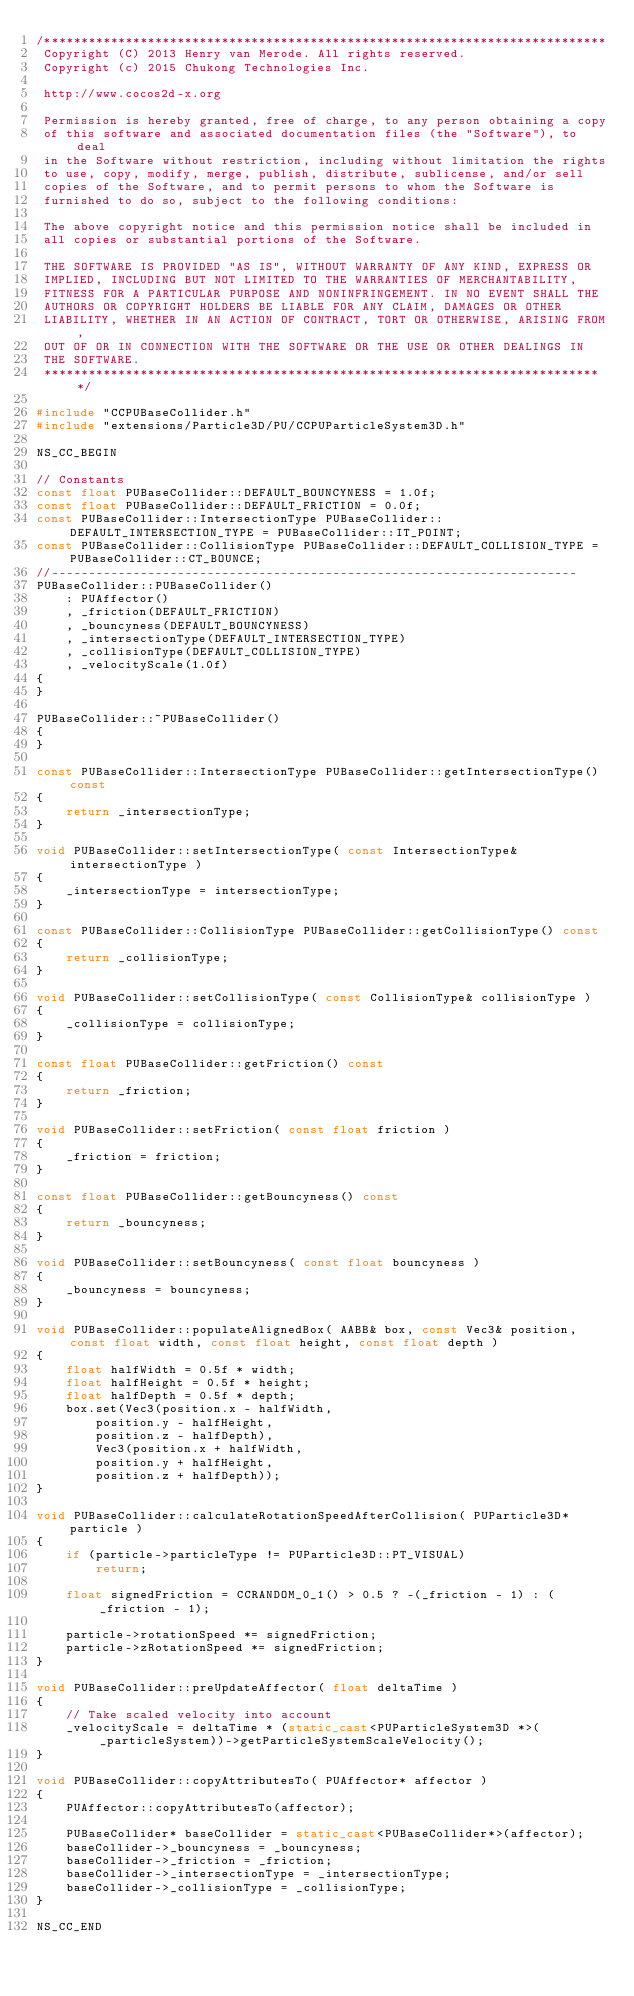Convert code to text. <code><loc_0><loc_0><loc_500><loc_500><_C++_>/****************************************************************************
 Copyright (C) 2013 Henry van Merode. All rights reserved.
 Copyright (c) 2015 Chukong Technologies Inc.
 
 http://www.cocos2d-x.org
 
 Permission is hereby granted, free of charge, to any person obtaining a copy
 of this software and associated documentation files (the "Software"), to deal
 in the Software without restriction, including without limitation the rights
 to use, copy, modify, merge, publish, distribute, sublicense, and/or sell
 copies of the Software, and to permit persons to whom the Software is
 furnished to do so, subject to the following conditions:
 
 The above copyright notice and this permission notice shall be included in
 all copies or substantial portions of the Software.
 
 THE SOFTWARE IS PROVIDED "AS IS", WITHOUT WARRANTY OF ANY KIND, EXPRESS OR
 IMPLIED, INCLUDING BUT NOT LIMITED TO THE WARRANTIES OF MERCHANTABILITY,
 FITNESS FOR A PARTICULAR PURPOSE AND NONINFRINGEMENT. IN NO EVENT SHALL THE
 AUTHORS OR COPYRIGHT HOLDERS BE LIABLE FOR ANY CLAIM, DAMAGES OR OTHER
 LIABILITY, WHETHER IN AN ACTION OF CONTRACT, TORT OR OTHERWISE, ARISING FROM,
 OUT OF OR IN CONNECTION WITH THE SOFTWARE OR THE USE OR OTHER DEALINGS IN
 THE SOFTWARE.
 ****************************************************************************/

#include "CCPUBaseCollider.h"
#include "extensions/Particle3D/PU/CCPUParticleSystem3D.h"

NS_CC_BEGIN

// Constants
const float PUBaseCollider::DEFAULT_BOUNCYNESS = 1.0f;
const float PUBaseCollider::DEFAULT_FRICTION = 0.0f;
const PUBaseCollider::IntersectionType PUBaseCollider::DEFAULT_INTERSECTION_TYPE = PUBaseCollider::IT_POINT;
const PUBaseCollider::CollisionType PUBaseCollider::DEFAULT_COLLISION_TYPE = PUBaseCollider::CT_BOUNCE;
//-----------------------------------------------------------------------
PUBaseCollider::PUBaseCollider() 
    : PUAffector()
    , _friction(DEFAULT_FRICTION)
    , _bouncyness(DEFAULT_BOUNCYNESS)
    , _intersectionType(DEFAULT_INTERSECTION_TYPE)
    , _collisionType(DEFAULT_COLLISION_TYPE)
    , _velocityScale(1.0f)
{
}

PUBaseCollider::~PUBaseCollider()
{
}

const PUBaseCollider::IntersectionType PUBaseCollider::getIntersectionType() const
{
    return _intersectionType;
}

void PUBaseCollider::setIntersectionType( const IntersectionType& intersectionType )
{
    _intersectionType = intersectionType;
}

const PUBaseCollider::CollisionType PUBaseCollider::getCollisionType() const
{
    return _collisionType;
}

void PUBaseCollider::setCollisionType( const CollisionType& collisionType )
{
    _collisionType = collisionType;
}

const float PUBaseCollider::getFriction() const
{
    return _friction;
}

void PUBaseCollider::setFriction( const float friction )
{
    _friction = friction;
}

const float PUBaseCollider::getBouncyness() const
{
    return _bouncyness;
}

void PUBaseCollider::setBouncyness( const float bouncyness )
{
    _bouncyness = bouncyness;
}

void PUBaseCollider::populateAlignedBox( AABB& box, const Vec3& position, const float width, const float height, const float depth )
{
    float halfWidth = 0.5f * width;
    float halfHeight = 0.5f * height;
    float halfDepth = 0.5f * depth;
    box.set(Vec3(position.x - halfWidth, 
        position.y - halfHeight, 
        position.z - halfDepth),
        Vec3(position.x + halfWidth, 
        position.y + halfHeight, 
        position.z + halfDepth));
}

void PUBaseCollider::calculateRotationSpeedAfterCollision( PUParticle3D* particle )
{
    if (particle->particleType != PUParticle3D::PT_VISUAL)
        return;

    float signedFriction = CCRANDOM_0_1() > 0.5 ? -(_friction - 1) : (_friction - 1);

    particle->rotationSpeed *= signedFriction;
    particle->zRotationSpeed *= signedFriction;
}

void PUBaseCollider::preUpdateAffector( float deltaTime )
{
    // Take scaled velocity into account
    _velocityScale = deltaTime * (static_cast<PUParticleSystem3D *>(_particleSystem))->getParticleSystemScaleVelocity();
}

void PUBaseCollider::copyAttributesTo( PUAffector* affector )
{
    PUAffector::copyAttributesTo(affector);

    PUBaseCollider* baseCollider = static_cast<PUBaseCollider*>(affector);
    baseCollider->_bouncyness = _bouncyness;
    baseCollider->_friction = _friction;
    baseCollider->_intersectionType = _intersectionType;
    baseCollider->_collisionType = _collisionType;
}

NS_CC_END
</code> 